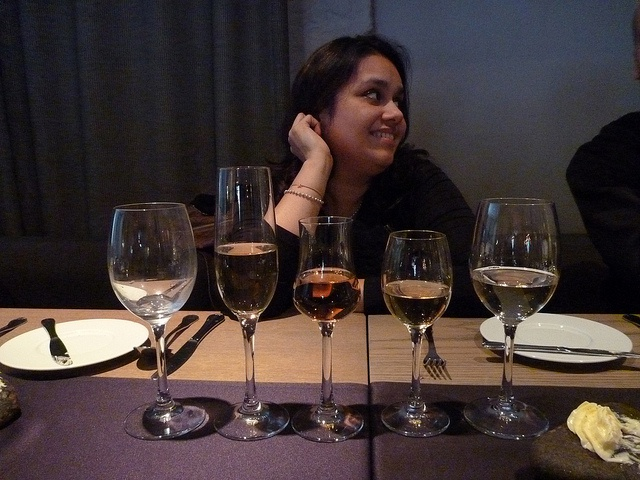Describe the objects in this image and their specific colors. I can see people in black, maroon, and brown tones, dining table in black, purple, and tan tones, wine glass in black and gray tones, wine glass in black and gray tones, and wine glass in black, gray, and darkgray tones in this image. 